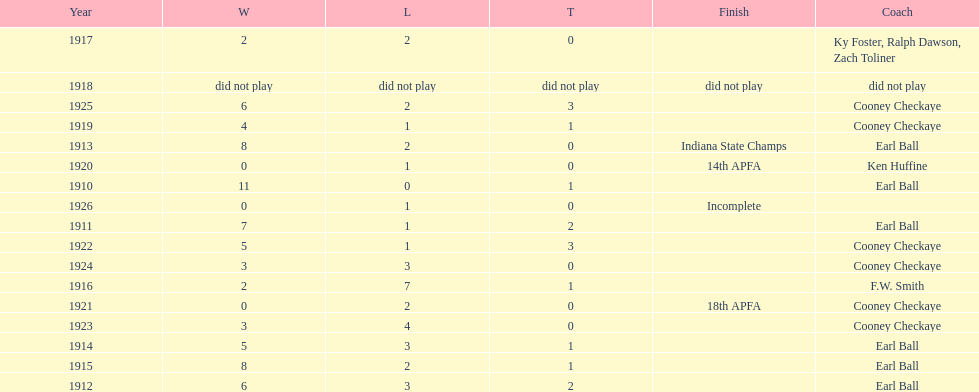Who coached the muncie flyers to an indiana state championship? Earl Ball. 